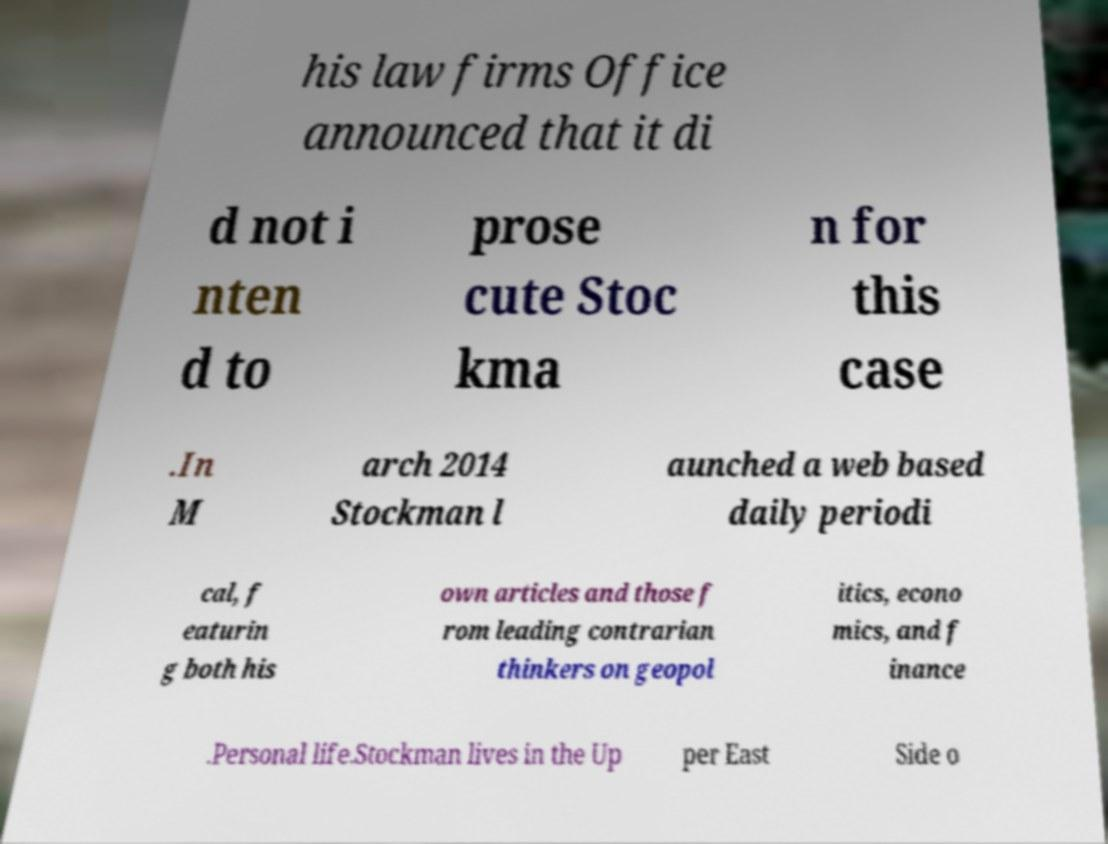Could you assist in decoding the text presented in this image and type it out clearly? his law firms Office announced that it di d not i nten d to prose cute Stoc kma n for this case .In M arch 2014 Stockman l aunched a web based daily periodi cal, f eaturin g both his own articles and those f rom leading contrarian thinkers on geopol itics, econo mics, and f inance .Personal life.Stockman lives in the Up per East Side o 